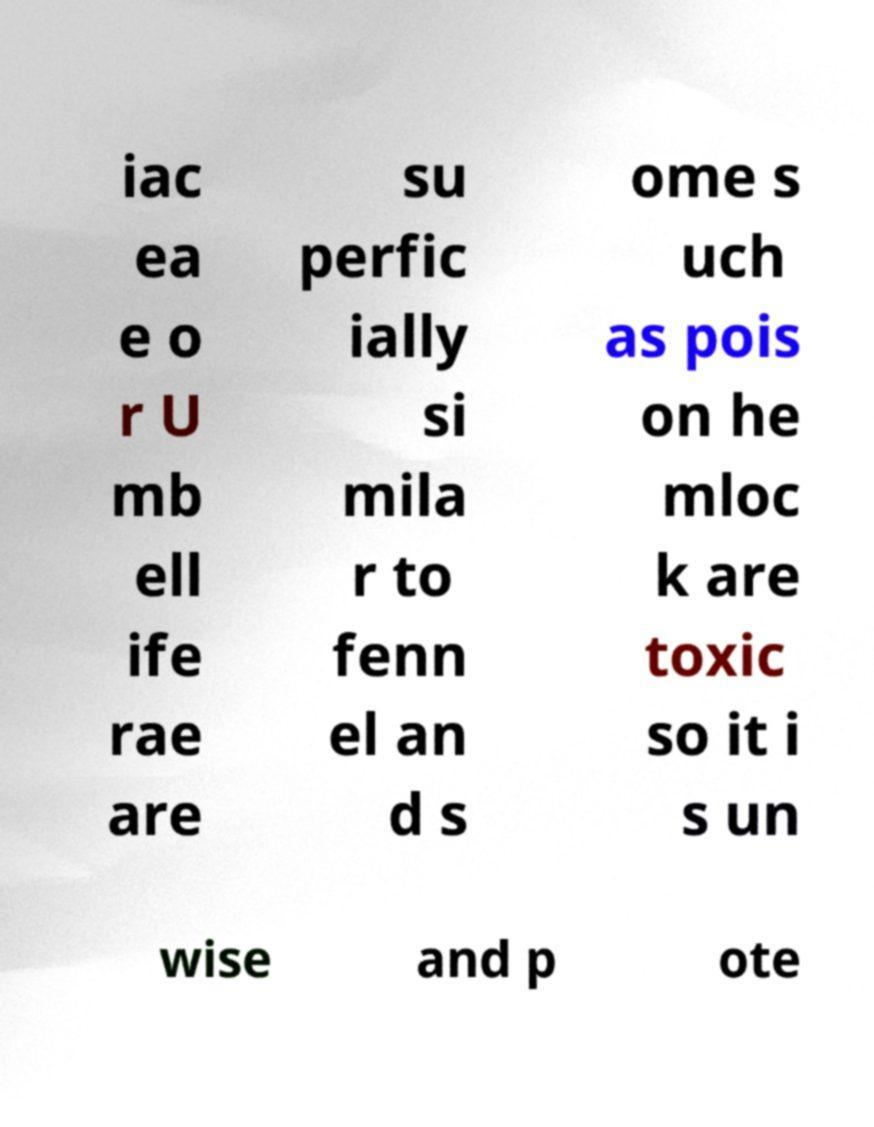Can you accurately transcribe the text from the provided image for me? iac ea e o r U mb ell ife rae are su perfic ially si mila r to fenn el an d s ome s uch as pois on he mloc k are toxic so it i s un wise and p ote 